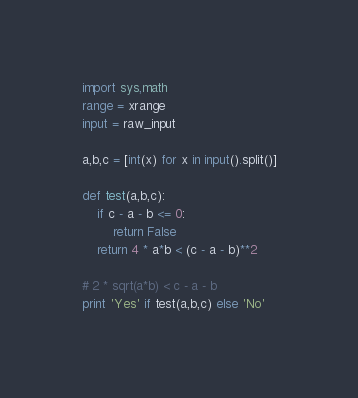<code> <loc_0><loc_0><loc_500><loc_500><_Python_>import sys,math
range = xrange
input = raw_input

a,b,c = [int(x) for x in input().split()]

def test(a,b,c):
    if c - a - b <= 0:
        return False
    return 4 * a*b < (c - a - b)**2 
    
# 2 * sqrt(a*b) < c - a - b
print 'Yes' if test(a,b,c) else 'No'
</code> 